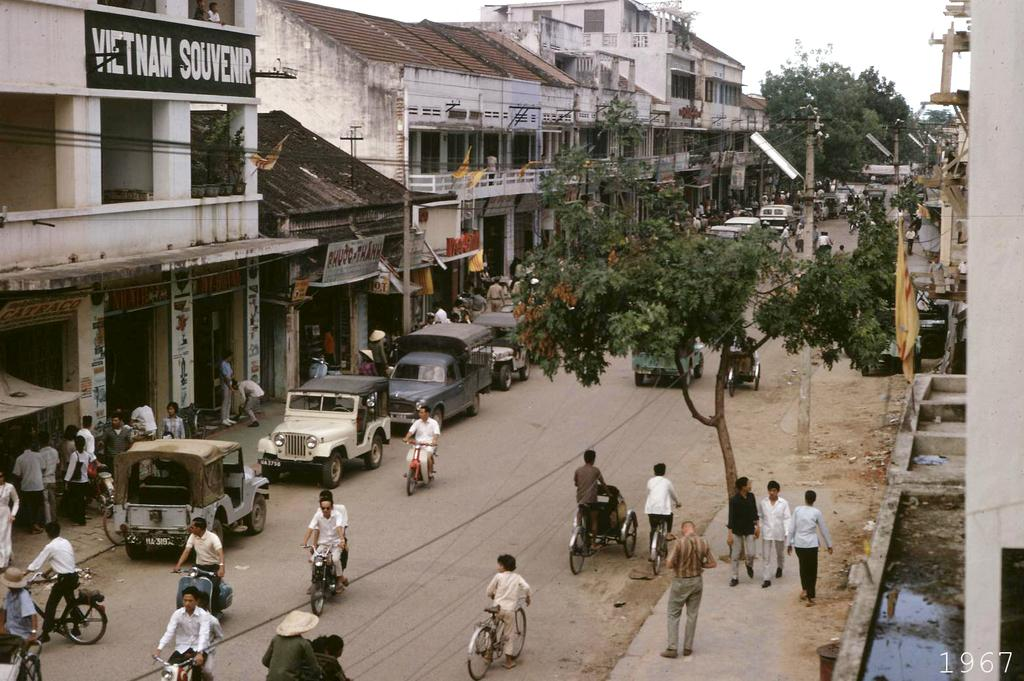<image>
Present a compact description of the photo's key features. A busy street with a souvenir shop to the left hand side. 